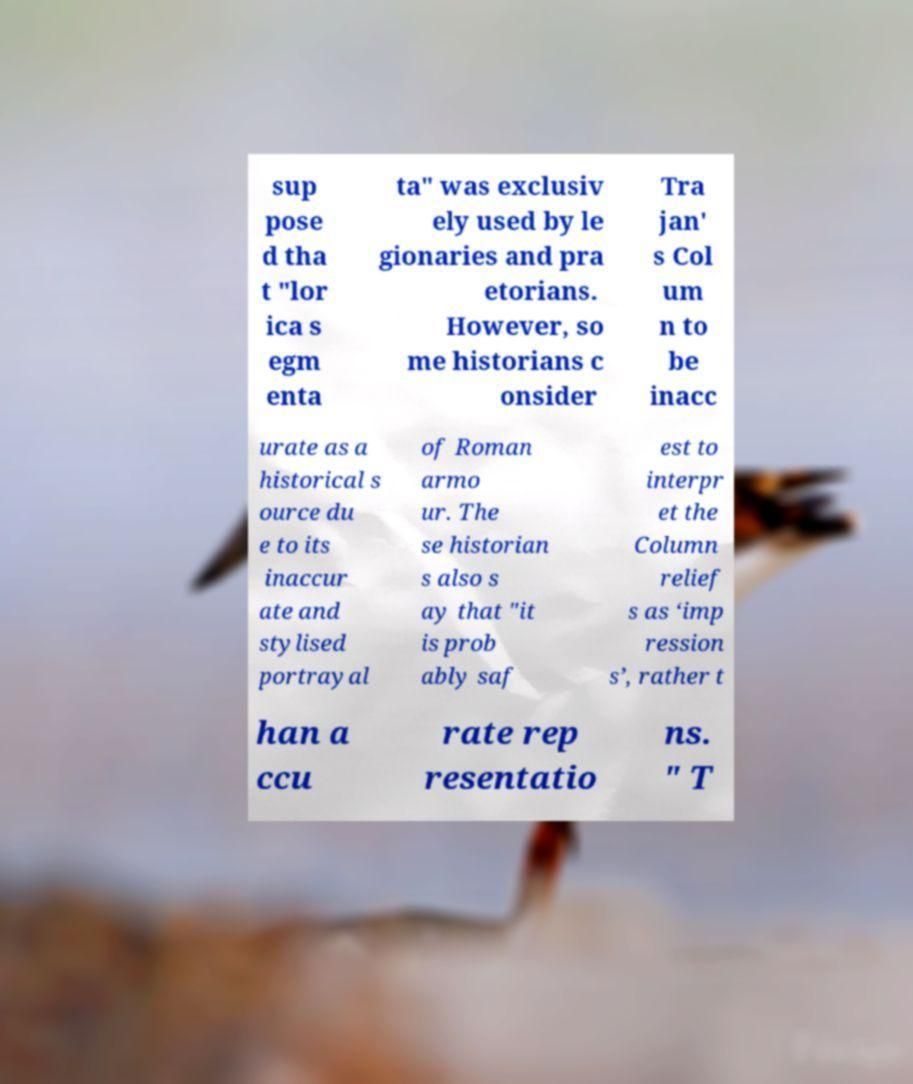Please identify and transcribe the text found in this image. sup pose d tha t "lor ica s egm enta ta" was exclusiv ely used by le gionaries and pra etorians. However, so me historians c onsider Tra jan' s Col um n to be inacc urate as a historical s ource du e to its inaccur ate and stylised portrayal of Roman armo ur. The se historian s also s ay that "it is prob ably saf est to interpr et the Column relief s as ‘imp ression s’, rather t han a ccu rate rep resentatio ns. " T 